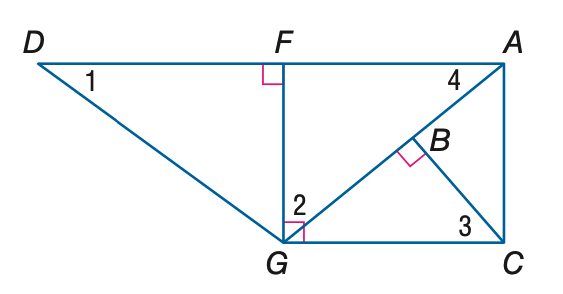Question: Find the measure of \angle 1 if m \angle D G F = 53 and m \angle A G C = 40.
Choices:
A. 37
B. 40
C. 50
D. 53
Answer with the letter. Answer: A Question: Find the measure of \angle 3 if m \angle D G F = 53 and m \angle A G C = 40.
Choices:
A. 37
B. 40
C. 50
D. 53
Answer with the letter. Answer: C Question: Find the measure of \angle 2 if m \angle D G F = 53 and m \angle A G C = 40.
Choices:
A. 37
B. 40
C. 50
D. 53
Answer with the letter. Answer: C Question: Find the measure of \angle 4 if m \angle D G F = 53 and m \angle A G C = 40.
Choices:
A. 37
B. 40
C. 50
D. 53
Answer with the letter. Answer: B 